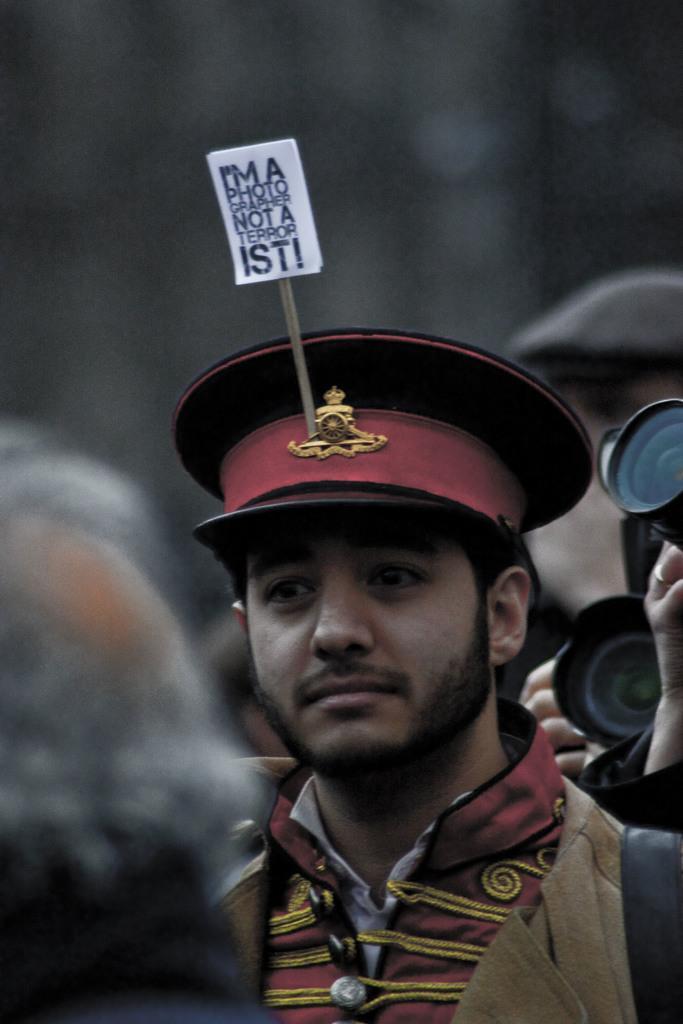Could you give a brief overview of what you see in this image? This image consists of a man wearing a cap. On which there is a placard. There are many people in this image. 